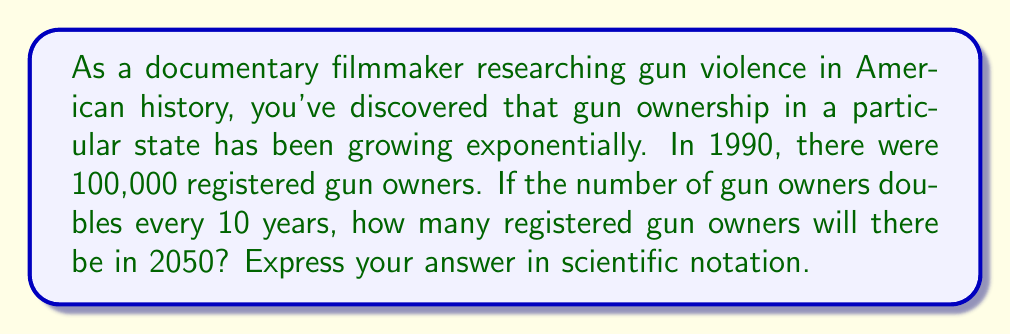Solve this math problem. To solve this problem, we need to use the exponential growth formula:

$$A = P \cdot (1 + r)^t$$

Where:
$A$ = Final amount
$P$ = Initial amount (100,000)
$r$ = Growth rate (100% or 1, as it doubles)
$t$ = Number of time periods

First, let's calculate how many 10-year periods are between 1990 and 2050:
$$(2050 - 1990) \div 10 = 6$$

Now we can plug these values into our formula:

$$A = 100,000 \cdot (1 + 1)^6$$
$$A = 100,000 \cdot 2^6$$

Simplify:
$$A = 100,000 \cdot 64 = 6,400,000$$

To express this in scientific notation:

$$6,400,000 = 6.4 \times 10^6$$
Answer: $6.4 \times 10^6$ registered gun owners 